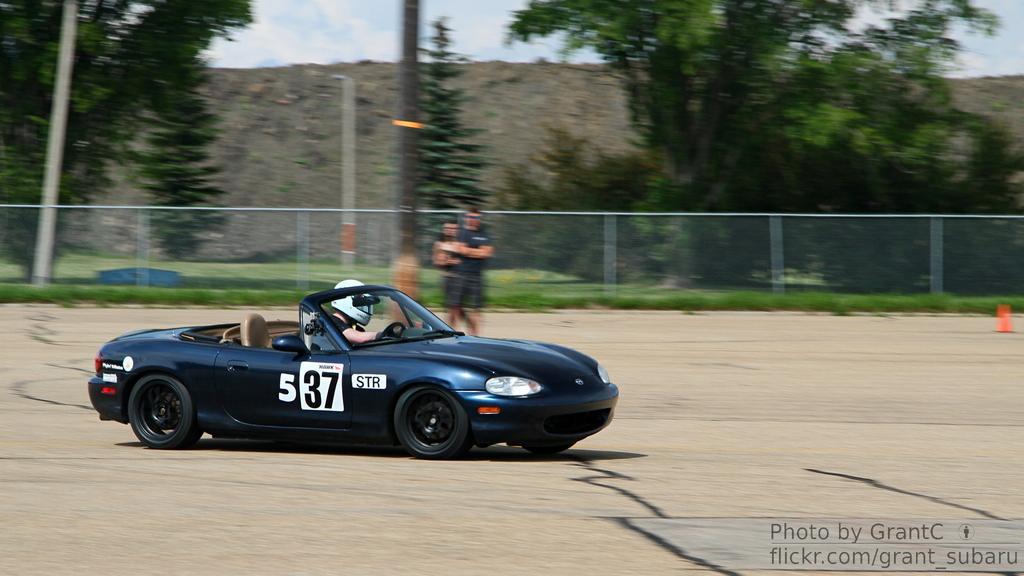Could you give a brief overview of what you see in this image? In this image I can see a person is driving the car, it is in black color, in the middle two persons are standing, behind them there is an iron fencing and there are trees at the back side, at the bottom there is water mark. 